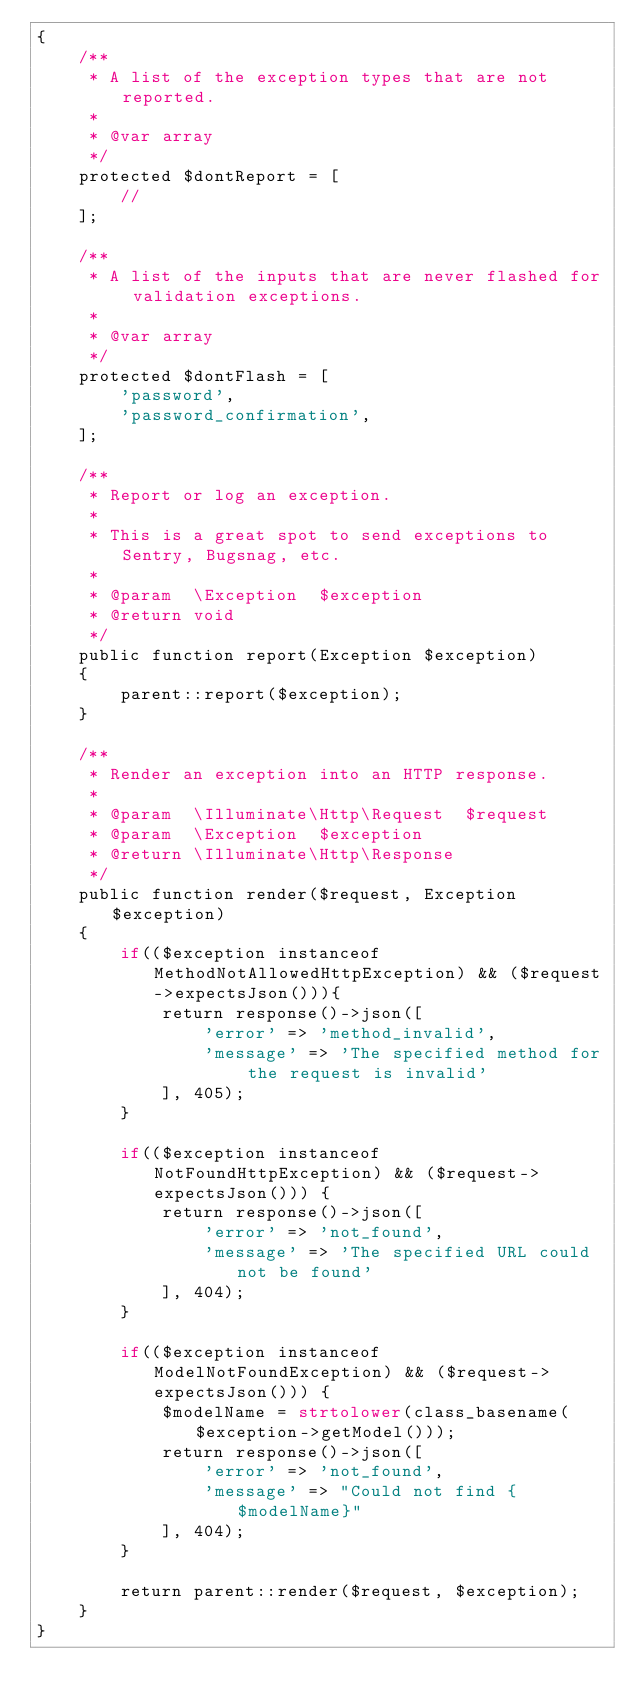Convert code to text. <code><loc_0><loc_0><loc_500><loc_500><_PHP_>{
    /**
     * A list of the exception types that are not reported.
     *
     * @var array
     */
    protected $dontReport = [
        //
    ];

    /**
     * A list of the inputs that are never flashed for validation exceptions.
     *
     * @var array
     */
    protected $dontFlash = [
        'password',
        'password_confirmation',
    ];

    /**
     * Report or log an exception.
     *
     * This is a great spot to send exceptions to Sentry, Bugsnag, etc.
     *
     * @param  \Exception  $exception
     * @return void
     */
    public function report(Exception $exception)
    {
        parent::report($exception);
    }

    /**
     * Render an exception into an HTTP response.
     *
     * @param  \Illuminate\Http\Request  $request
     * @param  \Exception  $exception
     * @return \Illuminate\Http\Response
     */
    public function render($request, Exception $exception)
    {
        if(($exception instanceof MethodNotAllowedHttpException) && ($request->expectsJson())){
            return response()->json([
                'error' => 'method_invalid',
                'message' => 'The specified method for the request is invalid'
            ], 405);
        }

        if(($exception instanceof NotFoundHttpException) && ($request->expectsJson())) {
            return response()->json([
                'error' => 'not_found',
                'message' => 'The specified URL could not be found'
            ], 404);
        }

        if(($exception instanceof ModelNotFoundException) && ($request->expectsJson())) {
            $modelName = strtolower(class_basename($exception->getModel()));
            return response()->json([
                'error' => 'not_found',
                'message' => "Could not find {$modelName}"
            ], 404);
        }

        return parent::render($request, $exception);
    }
}
</code> 